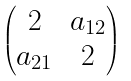Convert formula to latex. <formula><loc_0><loc_0><loc_500><loc_500>\begin{pmatrix} 2 & a _ { 1 2 } \\ a _ { 2 1 } & 2 \end{pmatrix}</formula> 